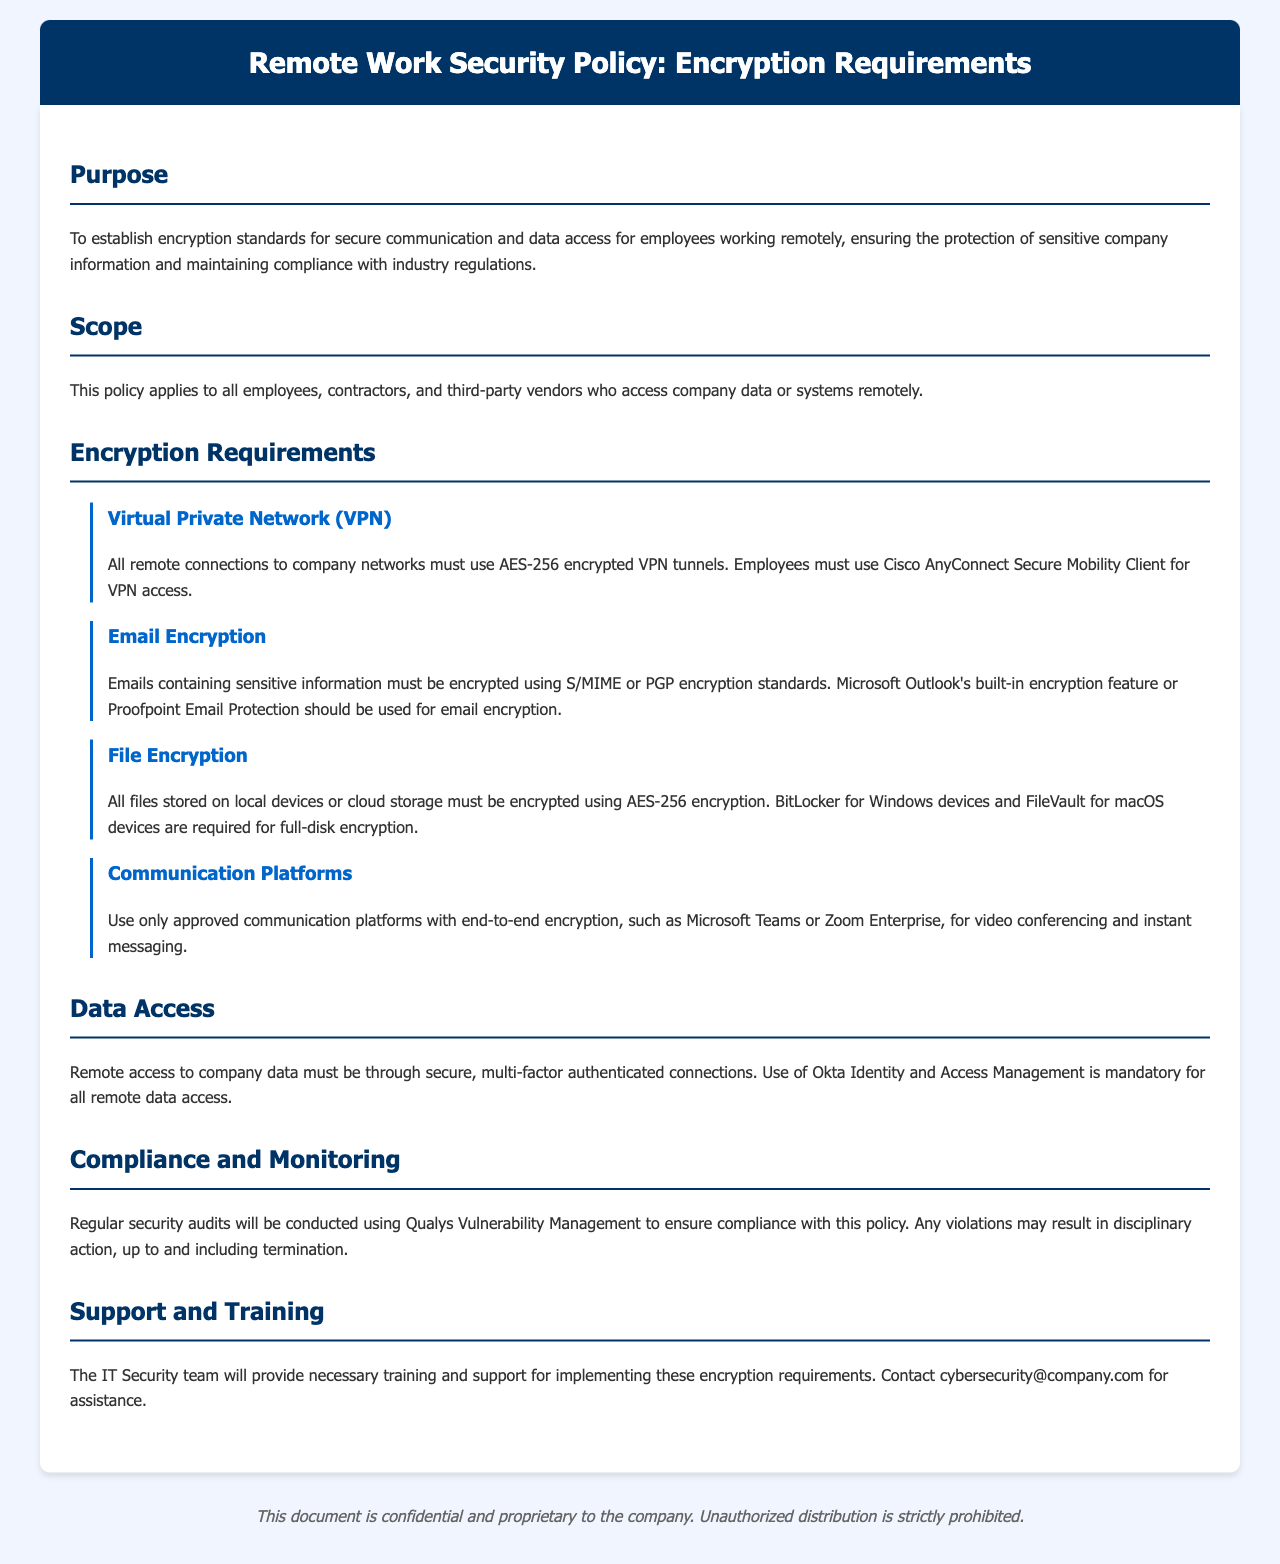What is the encryption standard for VPN tunnels? The encryption standard for VPN tunnels is specified in the document under "Virtual Private Network (VPN)". It states that all remote connections to company networks must use AES-256 encrypted VPN tunnels.
Answer: AES-256 Who is required to use Okta Identity and Access Management? The document under "Data Access" specifies that remote access to company data must use secure, multi-factor authenticated connections, and Okta Identity and Access Management is mandatory for all remote data access.
Answer: All employees What email encryption standards are mentioned in the document? The email encryption standards are detailed in the "Email Encryption" subsection, stating that emails containing sensitive information must be encrypted using S/MIME or PGP encryption standards.
Answer: S/MIME or PGP Which communication platforms are approved for use? The document specifies acceptable platforms under "Communication Platforms", stating to use only approved communication platforms with end-to-end encryption.
Answer: Microsoft Teams or Zoom Enterprise What is the consequence of policy violations? The "Compliance and Monitoring" section indicates that any violations may result in disciplinary action, providing specifics about repercussions for non-compliance.
Answer: Termination How often will security audits be conducted? The policy states regular security audits will be conducted but does not specify a time frame. It is mentioned under "Compliance and Monitoring".
Answer: Regularly 